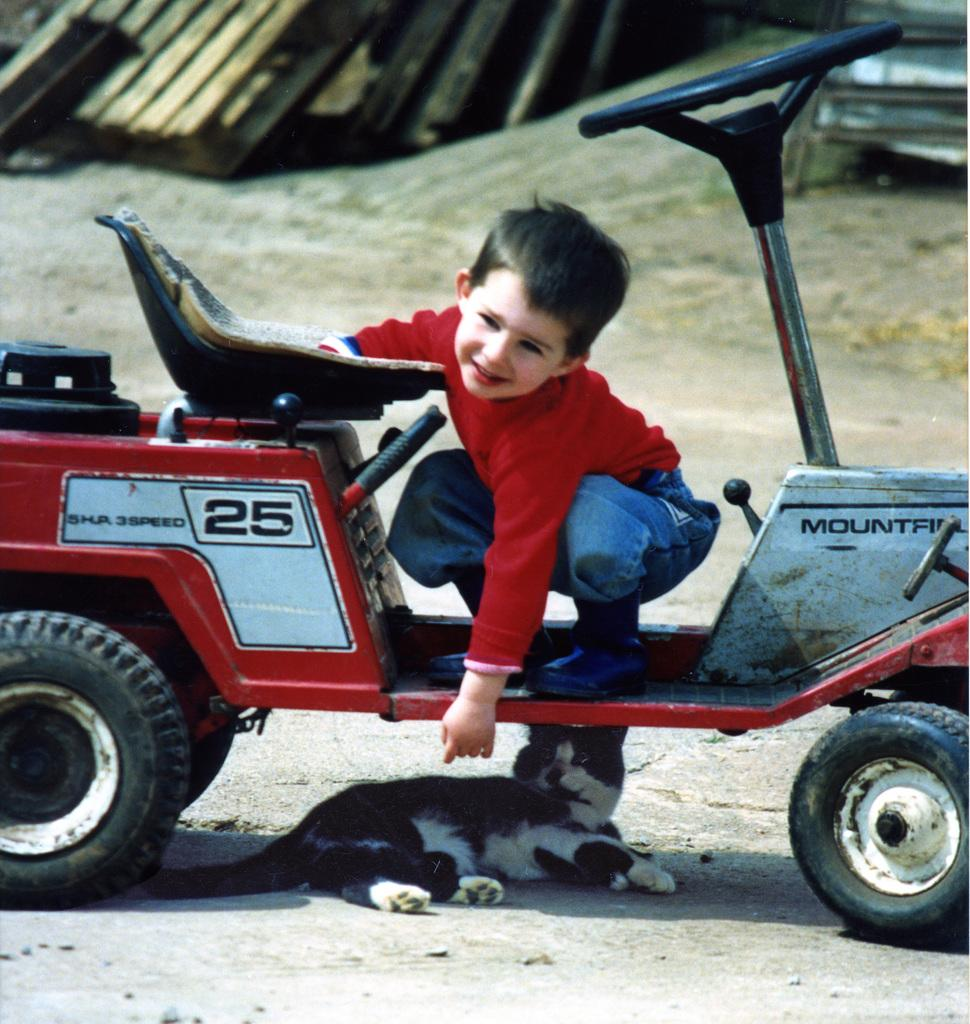Who is the main subject in the image? There is a small boy in the center of the image. What is the boy doing in the image? The boy is on a vehicle. Are there any animals present in the image? Yes, there is a cat under the vehicle. What can be seen at the top of the image? There are wooden boards at the top side of the image. What type of mark can be seen on the cat's fur in the image? There is no mark visible on the cat's fur in the image. How many quivers are present in the scene? There are no quivers present in the image. 